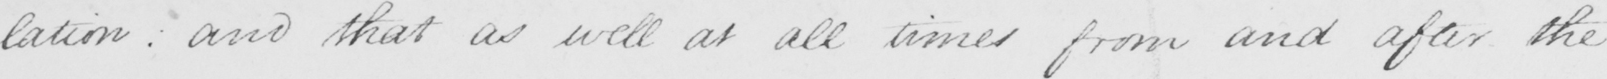What is written in this line of handwriting? -lation :  and that as well at all times from and after the 